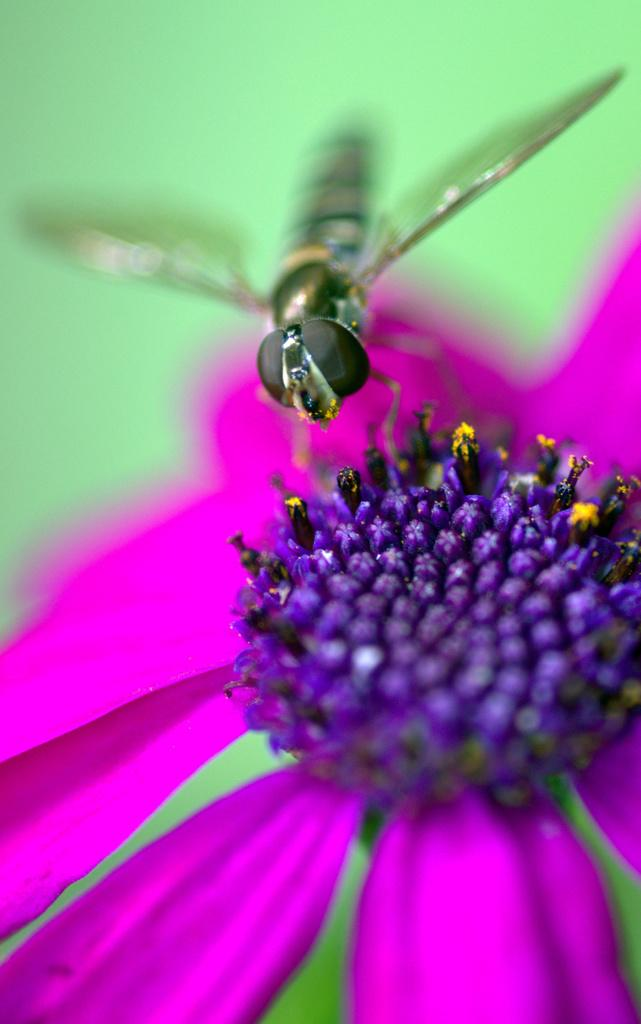What type of insect is in the image? There is a honeybee in the image. What is the honeybee doing in the image? The honeybee is sitting on a flower. What color is the flower the honeybee is sitting on? The flower is pink in color. What can be seen on the honeybee in the image? There are pollen grains in the image. What type of education does the gold receive in the image? There is no gold or education present in the image. 